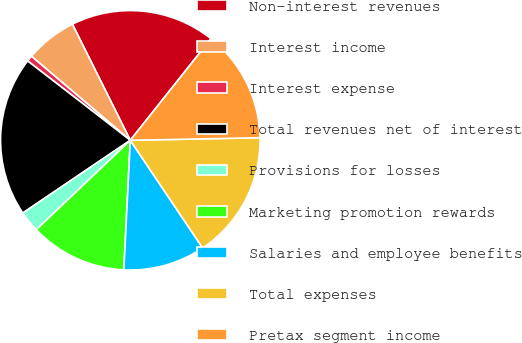Convert chart. <chart><loc_0><loc_0><loc_500><loc_500><pie_chart><fcel>Non-interest revenues<fcel>Interest income<fcel>Interest expense<fcel>Total revenues net of interest<fcel>Provisions for losses<fcel>Marketing promotion rewards<fcel>Salaries and employee benefits<fcel>Total expenses<fcel>Pretax segment income<nl><fcel>18.05%<fcel>6.42%<fcel>0.74%<fcel>19.94%<fcel>2.63%<fcel>12.11%<fcel>10.21%<fcel>15.9%<fcel>14.0%<nl></chart> 